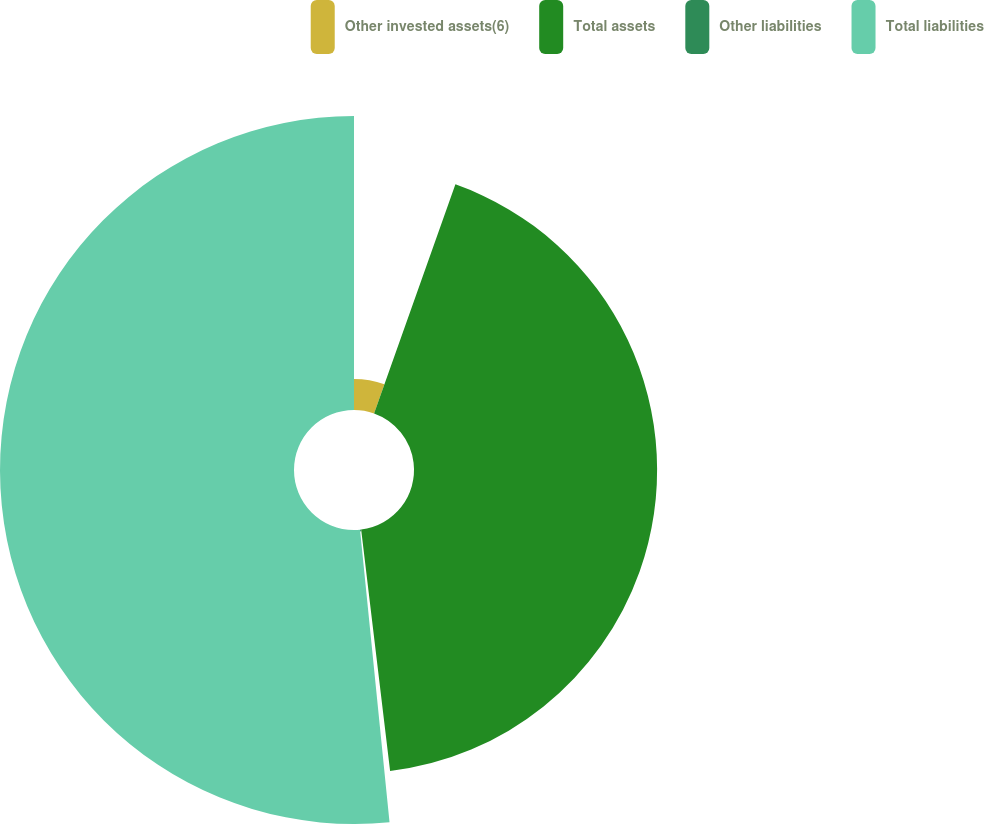Convert chart. <chart><loc_0><loc_0><loc_500><loc_500><pie_chart><fcel>Other invested assets(6)<fcel>Total assets<fcel>Other liabilities<fcel>Total liabilities<nl><fcel>5.43%<fcel>42.67%<fcel>0.3%<fcel>51.6%<nl></chart> 